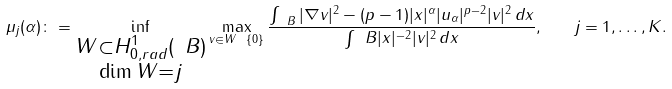<formula> <loc_0><loc_0><loc_500><loc_500>\mu _ { j } ( \alpha ) \colon = \inf _ { \substack { W \subset H _ { 0 , r a d } ^ { 1 } ( \ B ) \\ \dim W = j } } \max _ { v \in W \ \{ 0 \} } \frac { \int _ { \ B } | \nabla v | ^ { 2 } - ( p - 1 ) | x | ^ { \alpha } | u _ { \alpha } | ^ { p - 2 } | v | ^ { 2 } \, d x } { \int _ { \ } B | x | ^ { - 2 } | v | ^ { 2 } \, d x } , \quad j = 1 , \dots , K .</formula> 